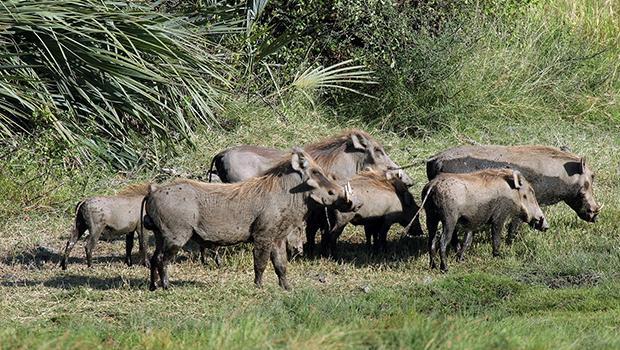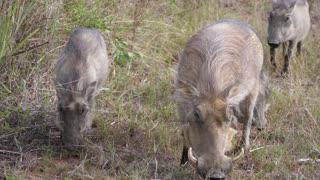The first image is the image on the left, the second image is the image on the right. For the images displayed, is the sentence "The image on the right has four or fewer warthogs." factually correct? Answer yes or no. Yes. The first image is the image on the left, the second image is the image on the right. For the images displayed, is the sentence "One of the images contains exactly four warthogs." factually correct? Answer yes or no. No. 